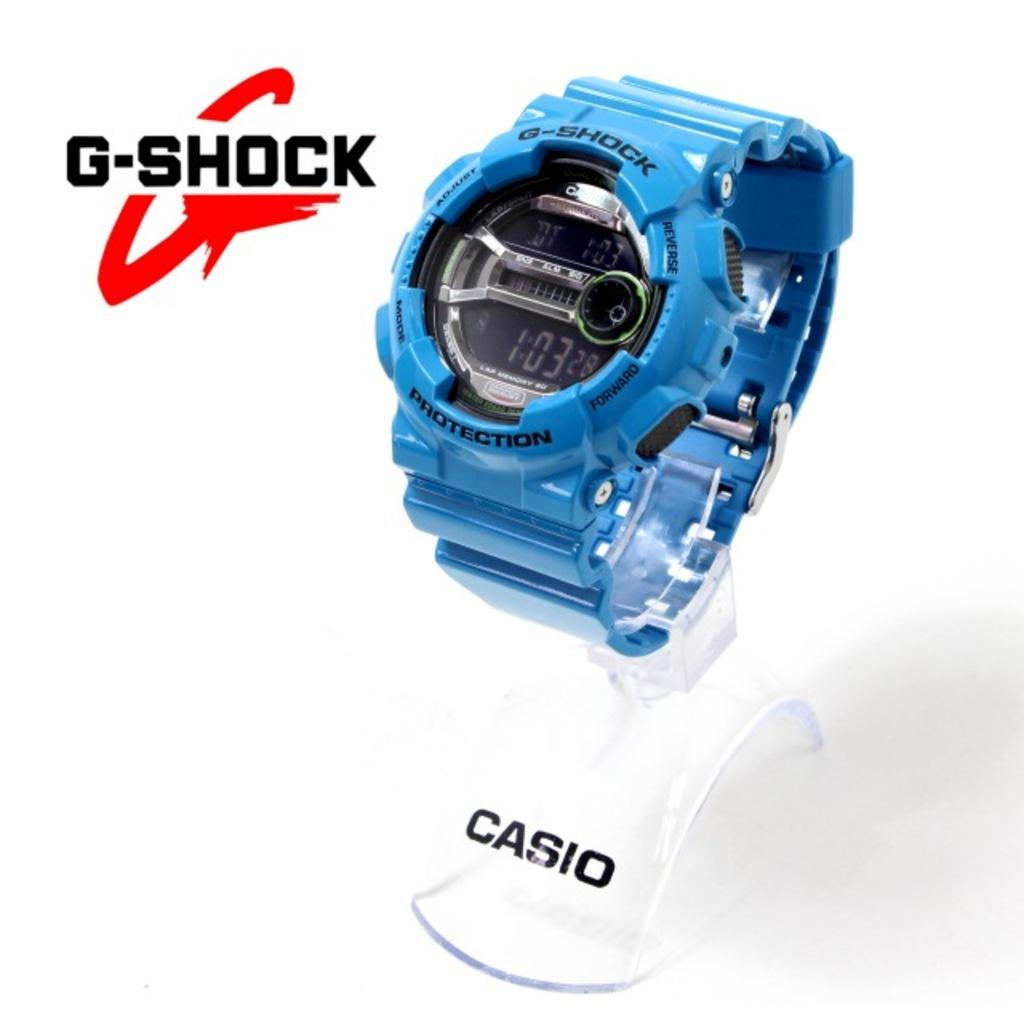<image>
Summarize the visual content of the image. a casio watch of the g-shock line showing 1:03 as the hour 